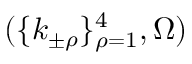Convert formula to latex. <formula><loc_0><loc_0><loc_500><loc_500>( \{ k _ { \pm \rho } \} _ { \rho = 1 } ^ { 4 } , \Omega )</formula> 